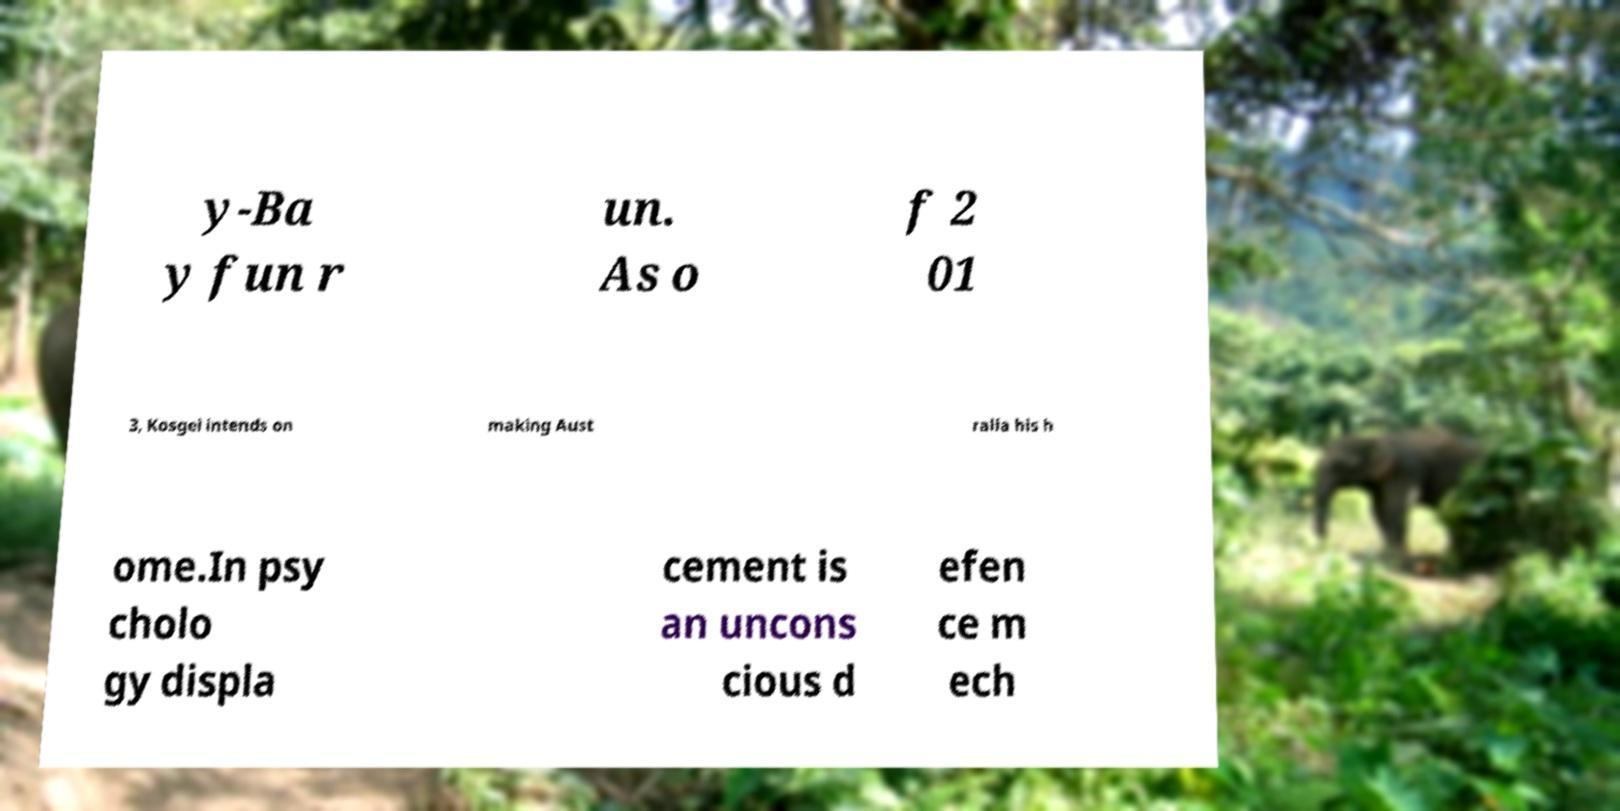Can you read and provide the text displayed in the image?This photo seems to have some interesting text. Can you extract and type it out for me? y-Ba y fun r un. As o f 2 01 3, Kosgei intends on making Aust ralia his h ome.In psy cholo gy displa cement is an uncons cious d efen ce m ech 